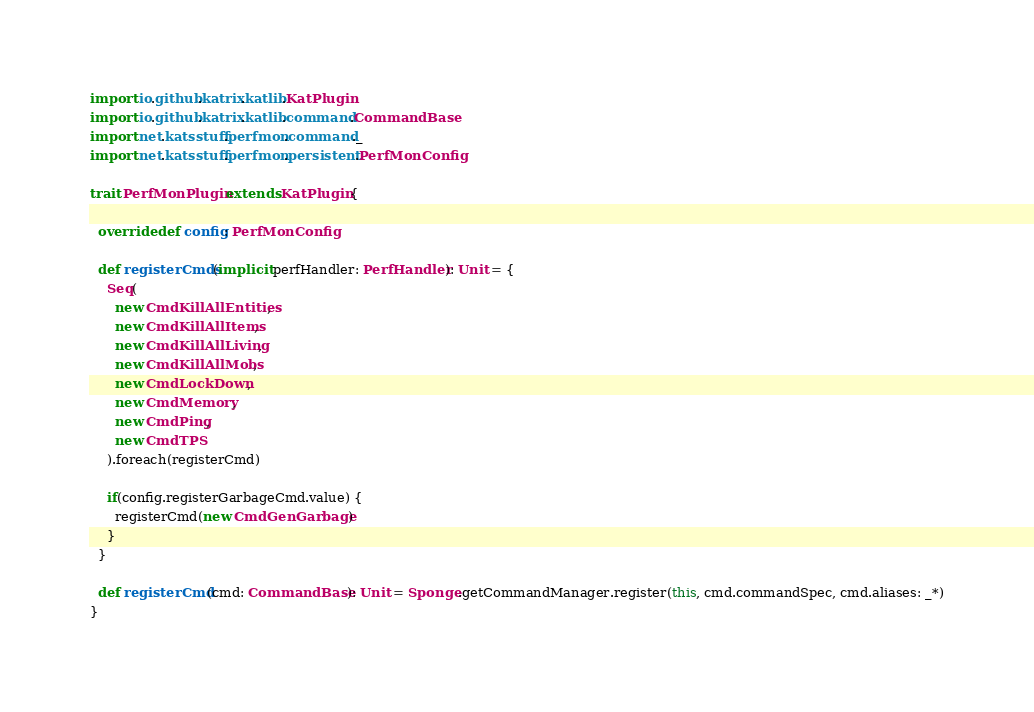Convert code to text. <code><loc_0><loc_0><loc_500><loc_500><_Scala_>import io.github.katrix.katlib.KatPlugin
import io.github.katrix.katlib.command.CommandBase
import net.katsstuff.perfmon.command._
import net.katsstuff.perfmon.persistent.PerfMonConfig

trait PerfMonPlugin extends KatPlugin {

  override def config: PerfMonConfig

  def registerCmds(implicit perfHandler: PerfHandler): Unit = {
    Seq(
      new CmdKillAllEntities,
      new CmdKillAllItems,
      new CmdKillAllLiving,
      new CmdKillAllMobs,
      new CmdLockDown,
      new CmdMemory,
      new CmdPing,
      new CmdTPS
    ).foreach(registerCmd)

    if(config.registerGarbageCmd.value) {
      registerCmd(new CmdGenGarbage)
    }
  }

  def registerCmd(cmd: CommandBase): Unit = Sponge.getCommandManager.register(this, cmd.commandSpec, cmd.aliases: _*)
}
</code> 